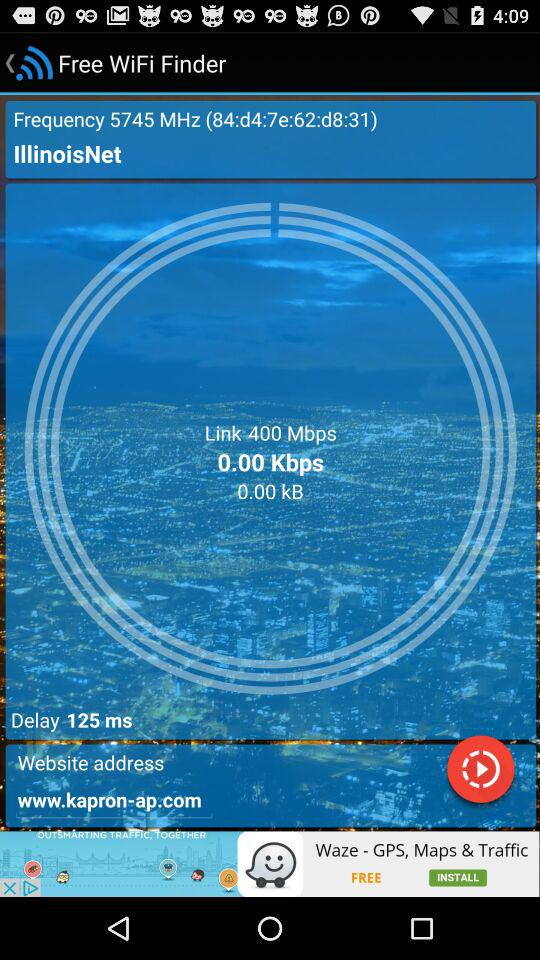What is the available WiFi connection? The available WiFi connection is IllinoisNet. 